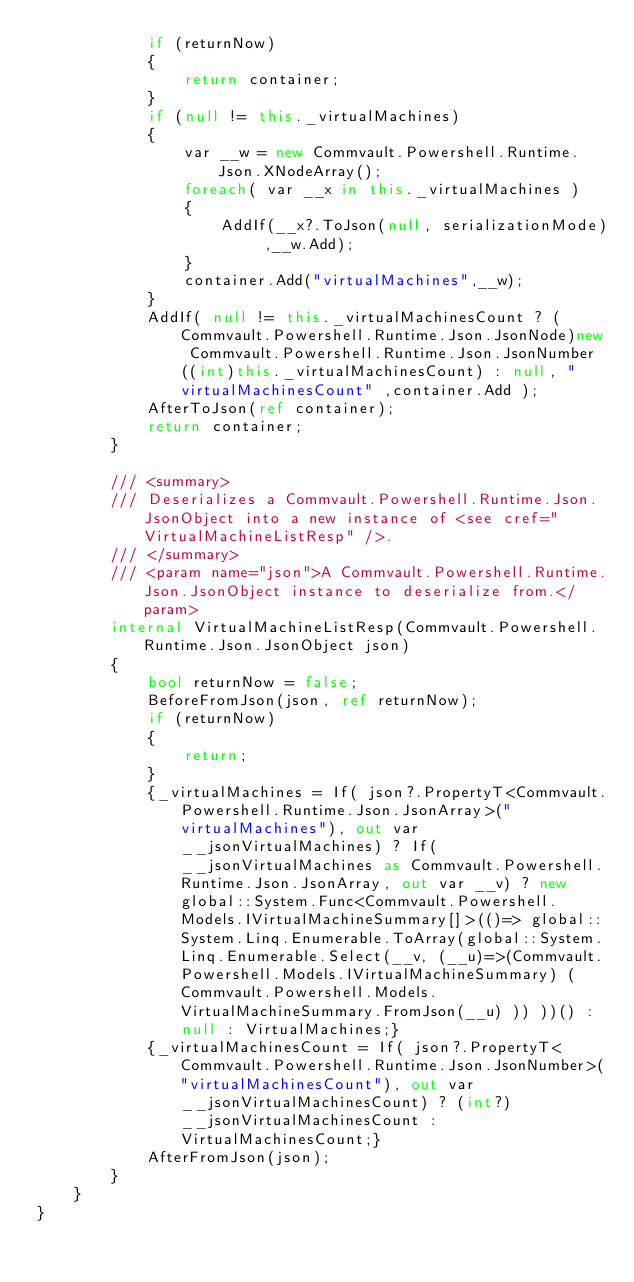Convert code to text. <code><loc_0><loc_0><loc_500><loc_500><_C#_>            if (returnNow)
            {
                return container;
            }
            if (null != this._virtualMachines)
            {
                var __w = new Commvault.Powershell.Runtime.Json.XNodeArray();
                foreach( var __x in this._virtualMachines )
                {
                    AddIf(__x?.ToJson(null, serializationMode) ,__w.Add);
                }
                container.Add("virtualMachines",__w);
            }
            AddIf( null != this._virtualMachinesCount ? (Commvault.Powershell.Runtime.Json.JsonNode)new Commvault.Powershell.Runtime.Json.JsonNumber((int)this._virtualMachinesCount) : null, "virtualMachinesCount" ,container.Add );
            AfterToJson(ref container);
            return container;
        }

        /// <summary>
        /// Deserializes a Commvault.Powershell.Runtime.Json.JsonObject into a new instance of <see cref="VirtualMachineListResp" />.
        /// </summary>
        /// <param name="json">A Commvault.Powershell.Runtime.Json.JsonObject instance to deserialize from.</param>
        internal VirtualMachineListResp(Commvault.Powershell.Runtime.Json.JsonObject json)
        {
            bool returnNow = false;
            BeforeFromJson(json, ref returnNow);
            if (returnNow)
            {
                return;
            }
            {_virtualMachines = If( json?.PropertyT<Commvault.Powershell.Runtime.Json.JsonArray>("virtualMachines"), out var __jsonVirtualMachines) ? If( __jsonVirtualMachines as Commvault.Powershell.Runtime.Json.JsonArray, out var __v) ? new global::System.Func<Commvault.Powershell.Models.IVirtualMachineSummary[]>(()=> global::System.Linq.Enumerable.ToArray(global::System.Linq.Enumerable.Select(__v, (__u)=>(Commvault.Powershell.Models.IVirtualMachineSummary) (Commvault.Powershell.Models.VirtualMachineSummary.FromJson(__u) )) ))() : null : VirtualMachines;}
            {_virtualMachinesCount = If( json?.PropertyT<Commvault.Powershell.Runtime.Json.JsonNumber>("virtualMachinesCount"), out var __jsonVirtualMachinesCount) ? (int?)__jsonVirtualMachinesCount : VirtualMachinesCount;}
            AfterFromJson(json);
        }
    }
}</code> 